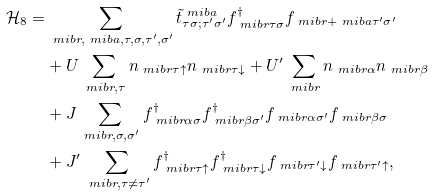<formula> <loc_0><loc_0><loc_500><loc_500>\mathcal { H } _ { 8 } = & \sum _ { \ m i b { r } , \ m i b { a } , \tau , \sigma , \tau ^ { \prime } , \sigma ^ { \prime } } { \tilde { t } } ^ { \ m i b { a } } _ { \tau \sigma ; \tau ^ { \prime } \sigma ^ { \prime } } f ^ { \dagger } _ { \ m i b { r } \tau \sigma } f _ { \ m i b { r } + \ m i b { a } \tau ^ { \prime } \sigma ^ { \prime } } \\ & + U \sum _ { \ m i b { r } , \tau } n _ { \ m i b { r } \tau \uparrow } n _ { \ m i b { r } \tau \downarrow } + U ^ { \prime } \sum _ { \ m i b { r } } n _ { \ m i b { r } \alpha } n _ { \ m i b { r } \beta } \\ & + J \sum _ { \ m i b { r } , \sigma , \sigma ^ { \prime } } f ^ { \dagger } _ { \ m i b { r } \alpha \sigma } f ^ { \dagger } _ { \ m i b { r } \beta \sigma ^ { \prime } } f _ { \ m i b { r } \alpha \sigma ^ { \prime } } f _ { \ m i b { r } \beta \sigma } \\ & + J ^ { \prime } \sum _ { \ m i b { r } , \tau \ne \tau ^ { \prime } } f ^ { \dagger } _ { \ m i b { r } \tau \uparrow } f ^ { \dagger } _ { \ m i b { r } \tau \downarrow } f _ { \ m i b { r } \tau ^ { \prime } \downarrow } f _ { \ m i b { r } \tau ^ { \prime } \uparrow } ,</formula> 